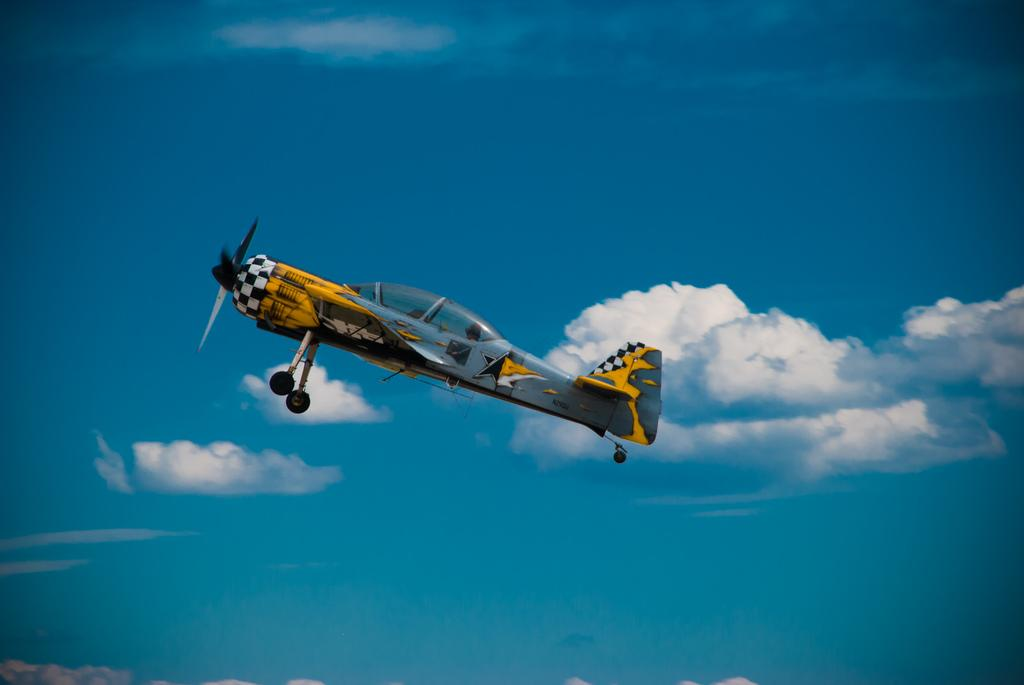What is flying in the sky in the image? There is a jet in the sky in the image. What can be seen on the right side of the image? There are clouds on the right side of the image. What type of potato is being used to play chess in the image? There is no potato or chess game present in the image. 